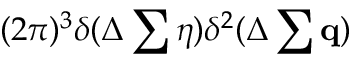<formula> <loc_0><loc_0><loc_500><loc_500>( 2 \pi ) ^ { 3 } \delta ( \Delta \sum \eta ) \delta ^ { 2 } ( \Delta \sum { q } )</formula> 